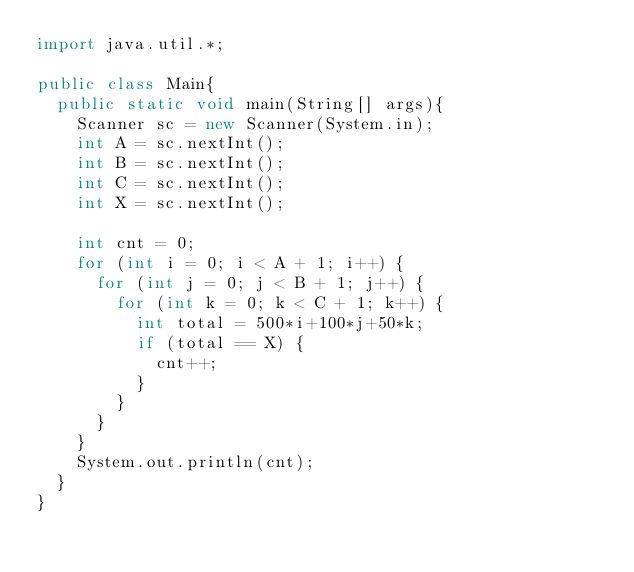Convert code to text. <code><loc_0><loc_0><loc_500><loc_500><_Java_>import java.util.*;
 
public class Main{
  public static void main(String[] args){
    Scanner sc = new Scanner(System.in);
    int A = sc.nextInt();
    int B = sc.nextInt();
    int C = sc.nextInt();
    int X = sc.nextInt();
    
    int cnt = 0;
    for (int i = 0; i < A + 1; i++) {
      for (int j = 0; j < B + 1; j++) {
        for (int k = 0; k < C + 1; k++) {
          int total = 500*i+100*j+50*k;
          if (total == X) {
            cnt++;
          }
        }
      }
    }
    System.out.println(cnt);
  }
}</code> 